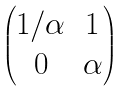Convert formula to latex. <formula><loc_0><loc_0><loc_500><loc_500>\begin{pmatrix} 1 / \alpha & 1 \\ 0 & \alpha \end{pmatrix}</formula> 